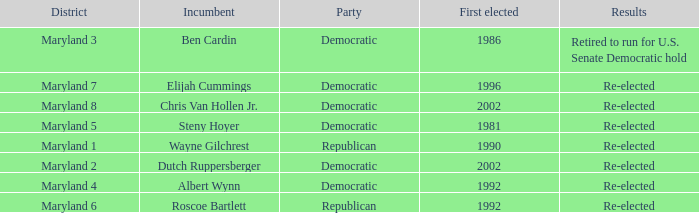What are the results of the incumbent who was first elected in 1996? Re-elected. 